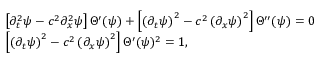<formula> <loc_0><loc_0><loc_500><loc_500>\begin{array} { r l } & { \left [ \partial _ { t } ^ { 2 } \psi - c ^ { 2 } \partial _ { x } ^ { 2 } \psi \right ] \Theta ^ { \prime } ( \psi ) + \left [ \left ( \partial _ { t } \psi \right ) ^ { 2 } - c ^ { 2 } \left ( \partial _ { x } \psi \right ) ^ { 2 } \right ] \Theta ^ { \prime \prime } ( \psi ) = 0 } \\ & { \left [ \left ( \partial _ { t } \psi \right ) ^ { 2 } - c ^ { 2 } \left ( \partial _ { x } \psi \right ) ^ { 2 } \right ] \Theta ^ { \prime } ( \psi ) ^ { 2 } = 1 , } \end{array}</formula> 